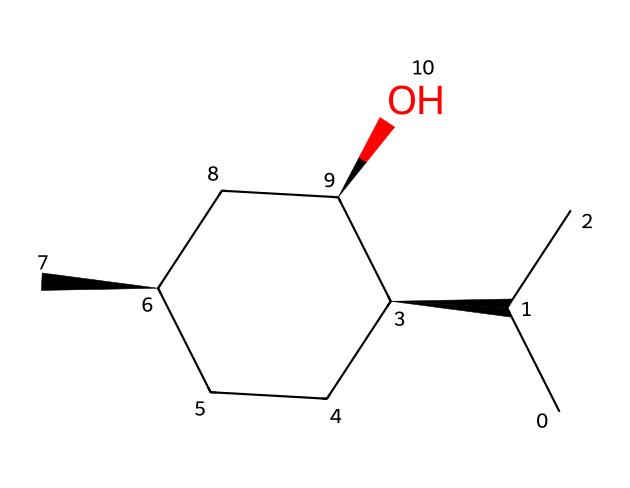What is the molecular formula of menthol? To derive the molecular formula from the SMILES representation, we count the different types of atoms present. The given SMILES indicates 10 carbon (C) atoms, 20 hydrogen (H) atoms, and 1 oxygen (O) atom. Therefore, the molecular formula is C10H20O.
Answer: C10H20O How many chiral centers are present in menthol? By examining the structure indicated by the SMILES, we identify the carbon atoms that have four different substituents, which are necessary for chirality. In the structure, there are three such carbon atoms, indicating that menthol has three chiral centers.
Answer: 3 What type of chemical compound is menthol? Menthol is classified as a terpenoid due to its structural features related to terpene compounds. It is also a cyclic monoterpene alcohol, indicative of its functional groups and rings.
Answer: terpenoid What is the degree of saturation in menthol? The degree of saturation can be calculated based on the number of pi bonds and rings in the structure. The presence of only single bonds in the cyclic part indicates high saturation, leading to a degree of saturation of 4 (as calculated by the formula for carbon atoms).
Answer: 4 Does menthol contain any hydroxyl groups? By analyzing the SMILES representation, we see the presence of the 'O' which indicates a hydroxyl (-OH) group. This confirms that menthol does indeed contain a hydroxyl group in its structure.
Answer: yes What is the total number of hydrogen atoms in menthol? The total hydrogen atoms can be deduced from the molecular formula derived earlier. In C10H20O, the number of hydrogen atoms is 20, reflecting the saturation of this compound.
Answer: 20 Is menthol a solid or liquid at room temperature? The typical physical state of menthol at room temperature is indicated through common knowledge of its properties and its structure. Menthol is known to be solid at room temperature due to its crystalline nature.
Answer: solid 